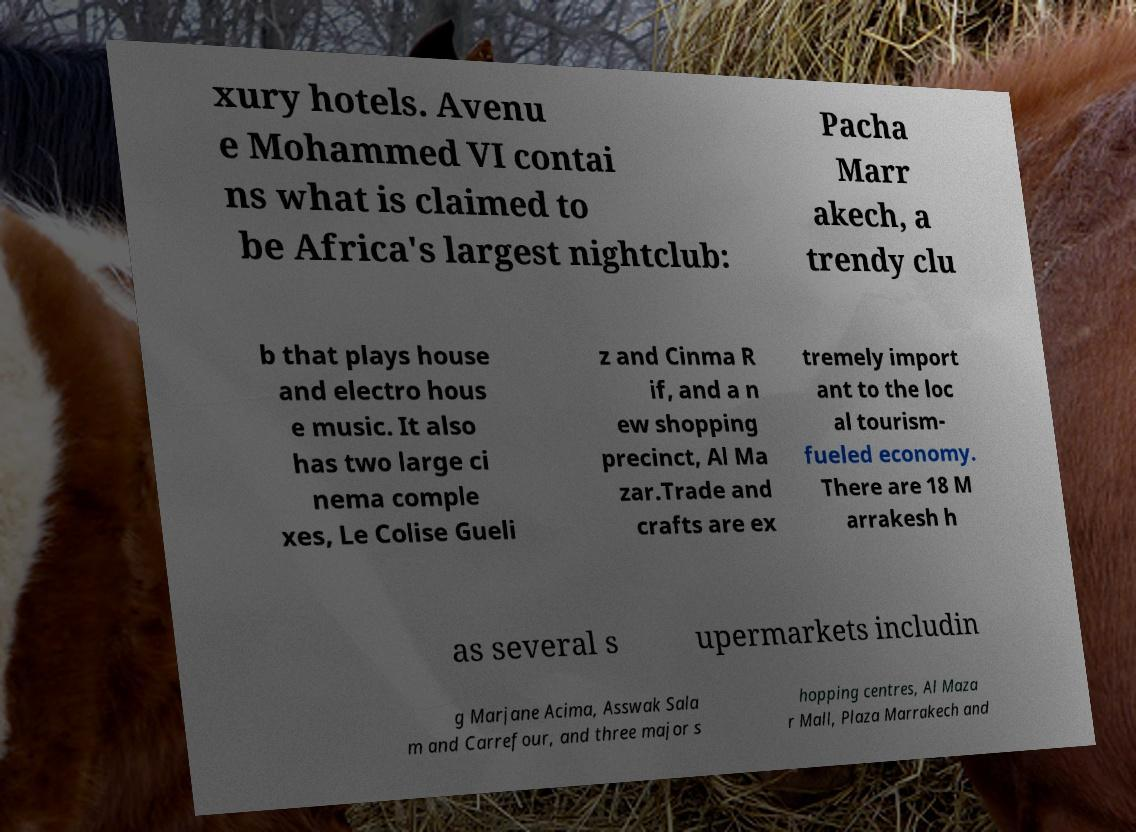There's text embedded in this image that I need extracted. Can you transcribe it verbatim? xury hotels. Avenu e Mohammed VI contai ns what is claimed to be Africa's largest nightclub: Pacha Marr akech, a trendy clu b that plays house and electro hous e music. It also has two large ci nema comple xes, Le Colise Gueli z and Cinma R if, and a n ew shopping precinct, Al Ma zar.Trade and crafts are ex tremely import ant to the loc al tourism- fueled economy. There are 18 M arrakesh h as several s upermarkets includin g Marjane Acima, Asswak Sala m and Carrefour, and three major s hopping centres, Al Maza r Mall, Plaza Marrakech and 